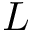Convert formula to latex. <formula><loc_0><loc_0><loc_500><loc_500>L</formula> 